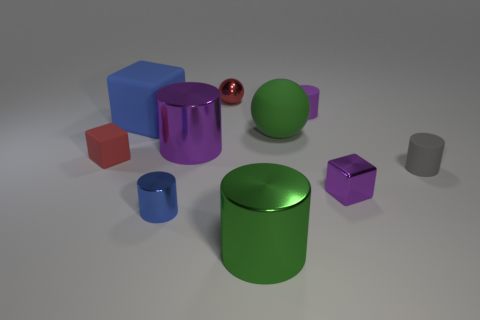There is a rubber thing right of the purple cylinder that is behind the large purple object; what number of small purple matte things are in front of it?
Provide a short and direct response. 0. How many big blue metal blocks are there?
Offer a very short reply. 0. Are there fewer small metallic objects that are behind the small blue object than green balls behind the rubber ball?
Provide a succinct answer. No. Are there fewer tiny rubber cylinders that are right of the small gray matte object than yellow objects?
Keep it short and to the point. No. The small cube on the left side of the tiny block to the right of the small metal object on the left side of the metallic ball is made of what material?
Offer a very short reply. Rubber. What number of objects are big objects that are in front of the tiny blue object or cubes that are to the right of the big green shiny cylinder?
Offer a very short reply. 2. There is a small red thing that is the same shape as the blue matte object; what is it made of?
Offer a terse response. Rubber. How many metallic things are large balls or small brown objects?
Offer a terse response. 0. The small red object that is made of the same material as the blue cube is what shape?
Provide a short and direct response. Cube. What number of other gray matte objects are the same shape as the gray matte thing?
Ensure brevity in your answer.  0. 